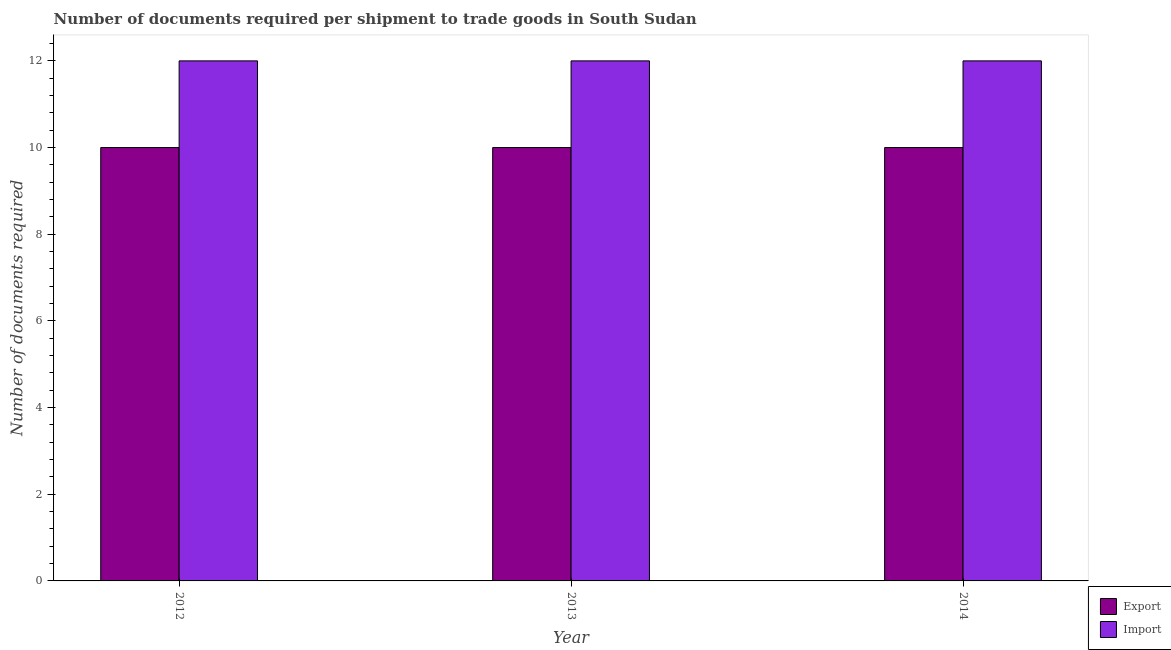How many groups of bars are there?
Provide a succinct answer. 3. Are the number of bars per tick equal to the number of legend labels?
Give a very brief answer. Yes. How many bars are there on the 1st tick from the right?
Give a very brief answer. 2. What is the label of the 3rd group of bars from the left?
Give a very brief answer. 2014. In how many cases, is the number of bars for a given year not equal to the number of legend labels?
Give a very brief answer. 0. What is the number of documents required to import goods in 2013?
Give a very brief answer. 12. Across all years, what is the maximum number of documents required to export goods?
Provide a short and direct response. 10. Across all years, what is the minimum number of documents required to export goods?
Provide a short and direct response. 10. What is the total number of documents required to import goods in the graph?
Offer a terse response. 36. What is the difference between the number of documents required to import goods in 2012 and that in 2014?
Provide a short and direct response. 0. In the year 2014, what is the difference between the number of documents required to import goods and number of documents required to export goods?
Provide a succinct answer. 0. In how many years, is the number of documents required to import goods greater than 0.4?
Provide a short and direct response. 3. What is the ratio of the number of documents required to import goods in 2012 to that in 2013?
Offer a terse response. 1. Is the difference between the number of documents required to export goods in 2012 and 2013 greater than the difference between the number of documents required to import goods in 2012 and 2013?
Give a very brief answer. No. In how many years, is the number of documents required to import goods greater than the average number of documents required to import goods taken over all years?
Keep it short and to the point. 0. Is the sum of the number of documents required to export goods in 2012 and 2014 greater than the maximum number of documents required to import goods across all years?
Your answer should be very brief. Yes. What does the 1st bar from the left in 2014 represents?
Make the answer very short. Export. What does the 2nd bar from the right in 2012 represents?
Offer a very short reply. Export. How many bars are there?
Offer a terse response. 6. How many years are there in the graph?
Your answer should be compact. 3. Are the values on the major ticks of Y-axis written in scientific E-notation?
Offer a very short reply. No. Does the graph contain any zero values?
Ensure brevity in your answer.  No. Does the graph contain grids?
Keep it short and to the point. No. Where does the legend appear in the graph?
Give a very brief answer. Bottom right. What is the title of the graph?
Give a very brief answer. Number of documents required per shipment to trade goods in South Sudan. Does "Official creditors" appear as one of the legend labels in the graph?
Your response must be concise. No. What is the label or title of the Y-axis?
Offer a very short reply. Number of documents required. What is the Number of documents required in Import in 2012?
Offer a terse response. 12. What is the Number of documents required of Export in 2013?
Ensure brevity in your answer.  10. What is the Number of documents required in Import in 2013?
Offer a very short reply. 12. What is the Number of documents required of Import in 2014?
Your answer should be compact. 12. Across all years, what is the maximum Number of documents required of Import?
Make the answer very short. 12. Across all years, what is the minimum Number of documents required in Export?
Your answer should be very brief. 10. What is the total Number of documents required of Export in the graph?
Make the answer very short. 30. What is the difference between the Number of documents required of Export in 2012 and that in 2013?
Keep it short and to the point. 0. What is the difference between the Number of documents required of Import in 2012 and that in 2013?
Your answer should be very brief. 0. What is the difference between the Number of documents required in Export in 2013 and that in 2014?
Your answer should be very brief. 0. What is the difference between the Number of documents required of Import in 2013 and that in 2014?
Offer a terse response. 0. What is the difference between the Number of documents required in Export in 2013 and the Number of documents required in Import in 2014?
Your response must be concise. -2. What is the average Number of documents required in Export per year?
Ensure brevity in your answer.  10. What is the average Number of documents required of Import per year?
Make the answer very short. 12. In the year 2013, what is the difference between the Number of documents required of Export and Number of documents required of Import?
Your answer should be compact. -2. What is the ratio of the Number of documents required in Import in 2012 to that in 2013?
Your response must be concise. 1. What is the ratio of the Number of documents required of Import in 2012 to that in 2014?
Your answer should be compact. 1. What is the difference between the highest and the second highest Number of documents required of Import?
Your answer should be very brief. 0. What is the difference between the highest and the lowest Number of documents required in Import?
Give a very brief answer. 0. 